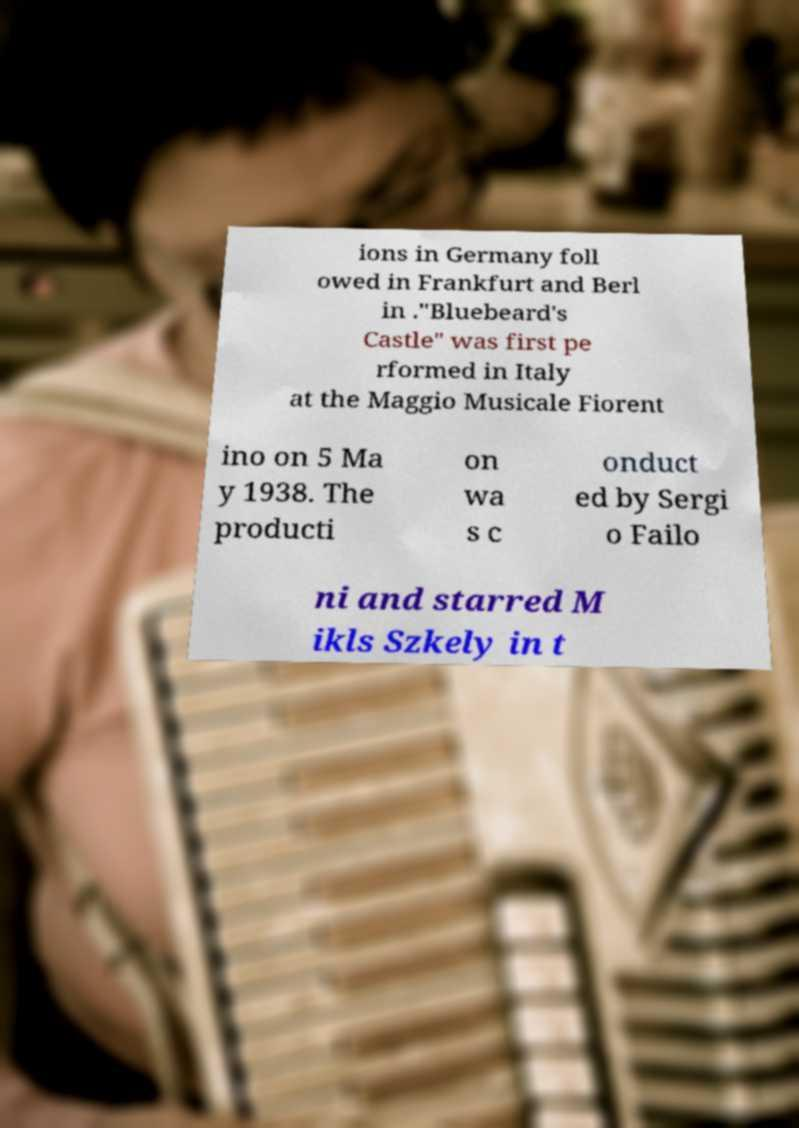Could you extract and type out the text from this image? ions in Germany foll owed in Frankfurt and Berl in ."Bluebeard's Castle" was first pe rformed in Italy at the Maggio Musicale Fiorent ino on 5 Ma y 1938. The producti on wa s c onduct ed by Sergi o Failo ni and starred M ikls Szkely in t 